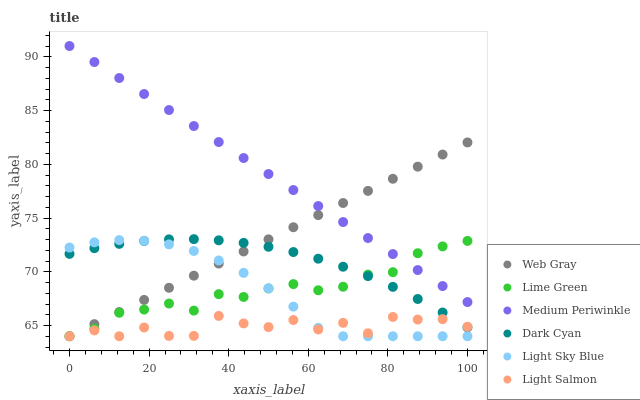Does Light Salmon have the minimum area under the curve?
Answer yes or no. Yes. Does Medium Periwinkle have the maximum area under the curve?
Answer yes or no. Yes. Does Web Gray have the minimum area under the curve?
Answer yes or no. No. Does Web Gray have the maximum area under the curve?
Answer yes or no. No. Is Medium Periwinkle the smoothest?
Answer yes or no. Yes. Is Light Salmon the roughest?
Answer yes or no. Yes. Is Web Gray the smoothest?
Answer yes or no. No. Is Web Gray the roughest?
Answer yes or no. No. Does Light Salmon have the lowest value?
Answer yes or no. Yes. Does Medium Periwinkle have the lowest value?
Answer yes or no. No. Does Medium Periwinkle have the highest value?
Answer yes or no. Yes. Does Web Gray have the highest value?
Answer yes or no. No. Is Dark Cyan less than Medium Periwinkle?
Answer yes or no. Yes. Is Medium Periwinkle greater than Light Salmon?
Answer yes or no. Yes. Does Web Gray intersect Lime Green?
Answer yes or no. Yes. Is Web Gray less than Lime Green?
Answer yes or no. No. Is Web Gray greater than Lime Green?
Answer yes or no. No. Does Dark Cyan intersect Medium Periwinkle?
Answer yes or no. No. 